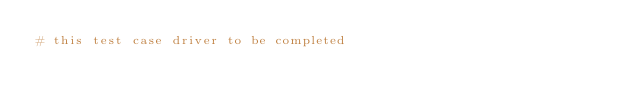Convert code to text. <code><loc_0><loc_0><loc_500><loc_500><_Bash_># this test case driver to be completed
</code> 